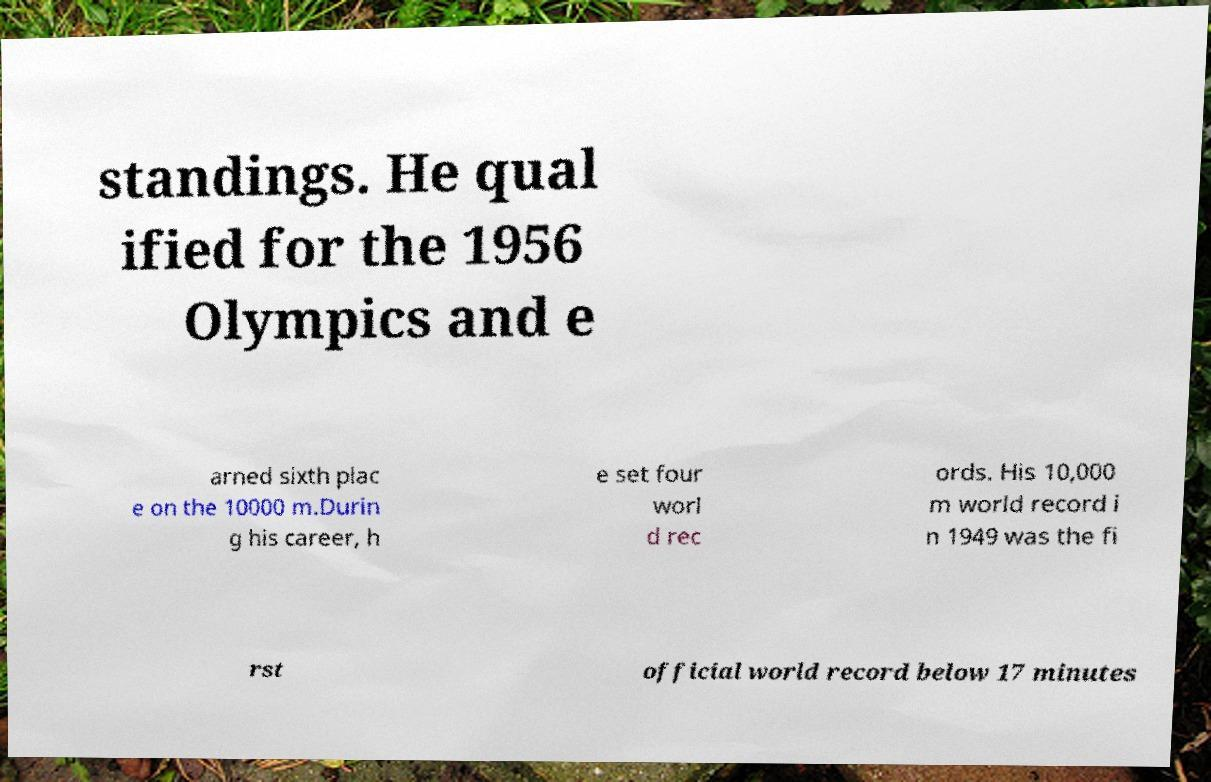Please read and relay the text visible in this image. What does it say? standings. He qual ified for the 1956 Olympics and e arned sixth plac e on the 10000 m.Durin g his career, h e set four worl d rec ords. His 10,000 m world record i n 1949 was the fi rst official world record below 17 minutes 